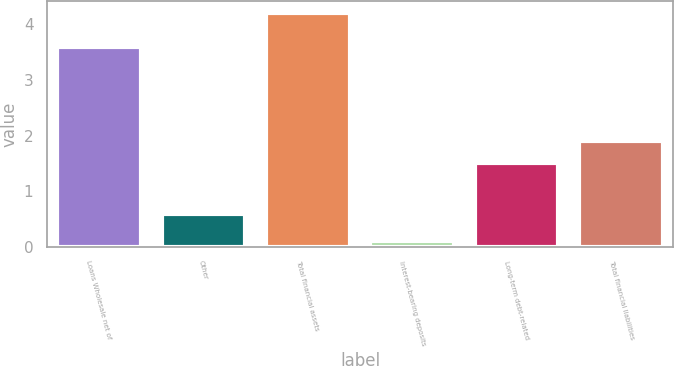<chart> <loc_0><loc_0><loc_500><loc_500><bar_chart><fcel>Loans Wholesale net of<fcel>Other<fcel>Total financial assets<fcel>Interest-bearing deposits<fcel>Long-term debt-related<fcel>Total financial liabilities<nl><fcel>3.6<fcel>0.6<fcel>4.2<fcel>0.1<fcel>1.5<fcel>1.91<nl></chart> 